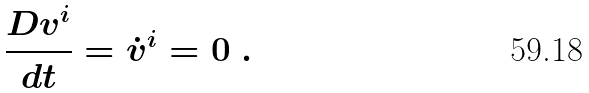<formula> <loc_0><loc_0><loc_500><loc_500>\frac { D v ^ { i } } { d t } = \dot { v } ^ { i } = 0 \ .</formula> 